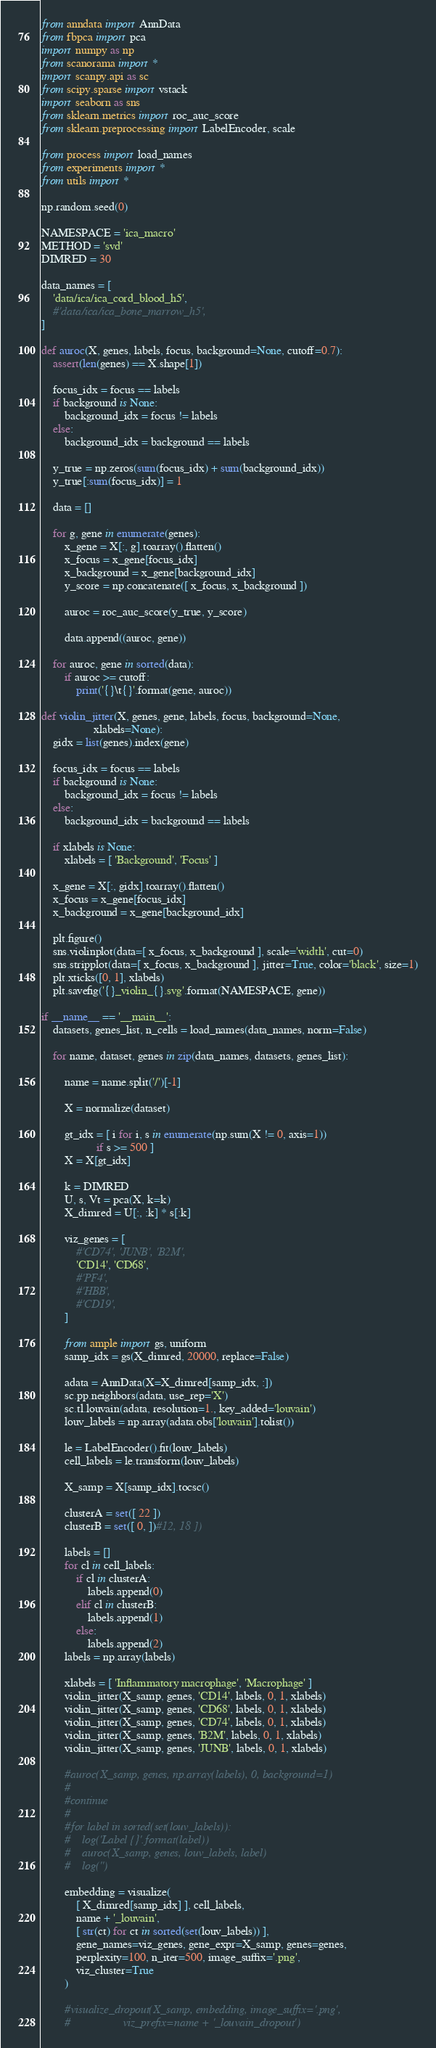<code> <loc_0><loc_0><loc_500><loc_500><_Python_>from anndata import AnnData
from fbpca import pca
import numpy as np
from scanorama import *
import scanpy.api as sc
from scipy.sparse import vstack
import seaborn as sns
from sklearn.metrics import roc_auc_score
from sklearn.preprocessing import LabelEncoder, scale

from process import load_names
from experiments import *
from utils import *

np.random.seed(0)

NAMESPACE = 'ica_macro'
METHOD = 'svd'
DIMRED = 30

data_names = [
    'data/ica/ica_cord_blood_h5',
    #'data/ica/ica_bone_marrow_h5',
]

def auroc(X, genes, labels, focus, background=None, cutoff=0.7):
    assert(len(genes) == X.shape[1])

    focus_idx = focus == labels
    if background is None:
        background_idx = focus != labels
    else:
        background_idx = background == labels

    y_true = np.zeros(sum(focus_idx) + sum(background_idx))
    y_true[:sum(focus_idx)] = 1

    data = []

    for g, gene in enumerate(genes):
        x_gene = X[:, g].toarray().flatten()
        x_focus = x_gene[focus_idx]
        x_background = x_gene[background_idx]
        y_score = np.concatenate([ x_focus, x_background ])
        
        auroc = roc_auc_score(y_true, y_score)

        data.append((auroc, gene))

    for auroc, gene in sorted(data):
        if auroc >= cutoff:
            print('{}\t{}'.format(gene, auroc))
        
def violin_jitter(X, genes, gene, labels, focus, background=None,
                  xlabels=None):
    gidx = list(genes).index(gene)

    focus_idx = focus == labels
    if background is None:
        background_idx = focus != labels
    else:
        background_idx = background == labels

    if xlabels is None:
        xlabels = [ 'Background', 'Focus' ]

    x_gene = X[:, gidx].toarray().flatten()
    x_focus = x_gene[focus_idx]
    x_background = x_gene[background_idx]
    
    plt.figure()
    sns.violinplot(data=[ x_focus, x_background ], scale='width', cut=0)
    sns.stripplot(data=[ x_focus, x_background ], jitter=True, color='black', size=1)
    plt.xticks([0, 1], xlabels)
    plt.savefig('{}_violin_{}.svg'.format(NAMESPACE, gene))
    
if __name__ == '__main__':
    datasets, genes_list, n_cells = load_names(data_names, norm=False)

    for name, dataset, genes in zip(data_names, datasets, genes_list):

        name = name.split('/')[-1]

        X = normalize(dataset)

        gt_idx = [ i for i, s in enumerate(np.sum(X != 0, axis=1))
                   if s >= 500 ]
        X = X[gt_idx]
        
        k = DIMRED
        U, s, Vt = pca(X, k=k)
        X_dimred = U[:, :k] * s[:k]

        viz_genes = [
            #'CD74', 'JUNB', 'B2M',
            'CD14', 'CD68',
            #'PF4',
            #'HBB',
            #'CD19',
        ]

        from ample import gs, uniform
        samp_idx = gs(X_dimred, 20000, replace=False)

        adata = AnnData(X=X_dimred[samp_idx, :])
        sc.pp.neighbors(adata, use_rep='X')
        sc.tl.louvain(adata, resolution=1., key_added='louvain')
        louv_labels = np.array(adata.obs['louvain'].tolist())

        le = LabelEncoder().fit(louv_labels)
        cell_labels = le.transform(louv_labels)

        X_samp = X[samp_idx].tocsc()
        
        clusterA = set([ 22 ])
        clusterB = set([ 0, ])#12, 18 ])
        
        labels = []
        for cl in cell_labels:
            if cl in clusterA:
                labels.append(0)
            elif cl in clusterB:
                labels.append(1)
            else:
                labels.append(2)
        labels = np.array(labels)

        xlabels = [ 'Inflammatory macrophage', 'Macrophage' ]
        violin_jitter(X_samp, genes, 'CD14', labels, 0, 1, xlabels)
        violin_jitter(X_samp, genes, 'CD68', labels, 0, 1, xlabels)
        violin_jitter(X_samp, genes, 'CD74', labels, 0, 1, xlabels)
        violin_jitter(X_samp, genes, 'B2M', labels, 0, 1, xlabels)
        violin_jitter(X_samp, genes, 'JUNB', labels, 0, 1, xlabels)
        
        #auroc(X_samp, genes, np.array(labels), 0, background=1)
        #
        #continue
        #
        #for label in sorted(set(louv_labels)):
        #    log('Label {}'.format(label))
        #    auroc(X_samp, genes, louv_labels, label)
        #    log('')

        embedding = visualize(
            [ X_dimred[samp_idx] ], cell_labels,
            name + '_louvain',
            [ str(ct) for ct in sorted(set(louv_labels)) ],
            gene_names=viz_genes, gene_expr=X_samp, genes=genes,
            perplexity=100, n_iter=500, image_suffix='.png',
            viz_cluster=True
        )
        
        #visualize_dropout(X_samp, embedding, image_suffix='.png',
        #                  viz_prefix=name + '_louvain_dropout')
</code> 